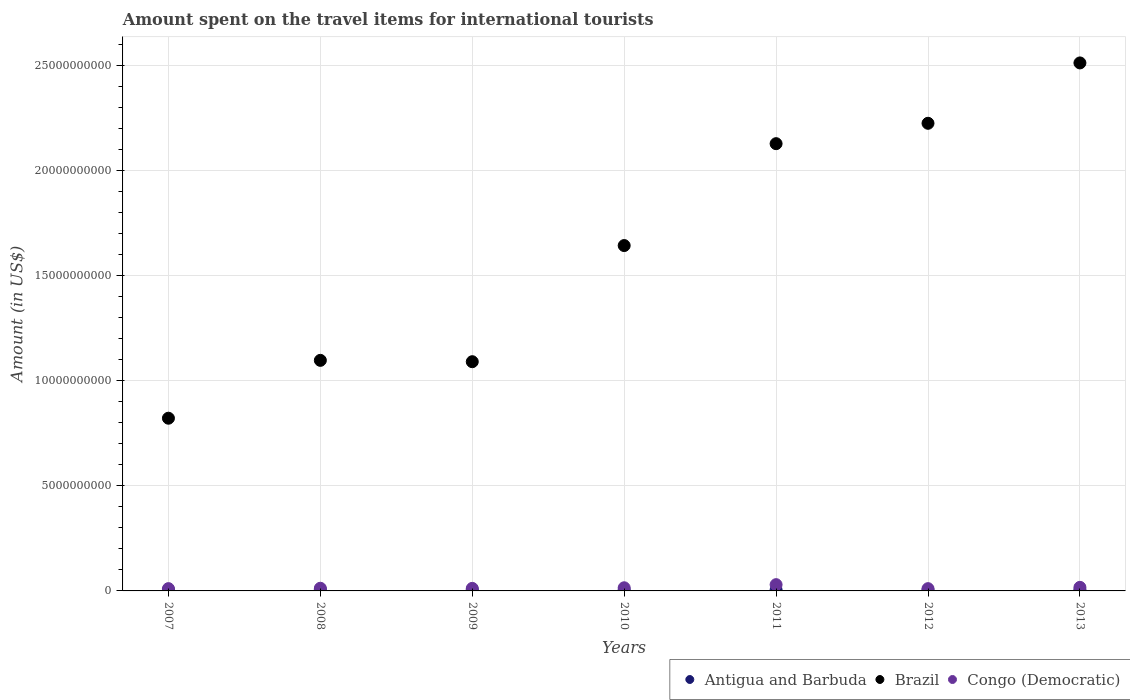How many different coloured dotlines are there?
Ensure brevity in your answer.  3. Is the number of dotlines equal to the number of legend labels?
Ensure brevity in your answer.  Yes. What is the amount spent on the travel items for international tourists in Antigua and Barbuda in 2012?
Offer a very short reply. 4.90e+07. Across all years, what is the maximum amount spent on the travel items for international tourists in Antigua and Barbuda?
Ensure brevity in your answer.  5.80e+07. Across all years, what is the minimum amount spent on the travel items for international tourists in Congo (Democratic)?
Give a very brief answer. 1.08e+08. In which year was the amount spent on the travel items for international tourists in Brazil minimum?
Make the answer very short. 2007. What is the total amount spent on the travel items for international tourists in Antigua and Barbuda in the graph?
Your answer should be compact. 3.63e+08. What is the difference between the amount spent on the travel items for international tourists in Congo (Democratic) in 2011 and that in 2013?
Your response must be concise. 1.28e+08. What is the difference between the amount spent on the travel items for international tourists in Antigua and Barbuda in 2011 and the amount spent on the travel items for international tourists in Congo (Democratic) in 2009?
Offer a terse response. -7.20e+07. What is the average amount spent on the travel items for international tourists in Antigua and Barbuda per year?
Your answer should be very brief. 5.19e+07. In the year 2011, what is the difference between the amount spent on the travel items for international tourists in Antigua and Barbuda and amount spent on the travel items for international tourists in Brazil?
Ensure brevity in your answer.  -2.12e+1. In how many years, is the amount spent on the travel items for international tourists in Antigua and Barbuda greater than 3000000000 US$?
Your response must be concise. 0. What is the ratio of the amount spent on the travel items for international tourists in Congo (Democratic) in 2008 to that in 2012?
Your answer should be compact. 1.18. Is the difference between the amount spent on the travel items for international tourists in Antigua and Barbuda in 2007 and 2012 greater than the difference between the amount spent on the travel items for international tourists in Brazil in 2007 and 2012?
Provide a short and direct response. Yes. What is the difference between the highest and the second highest amount spent on the travel items for international tourists in Brazil?
Your answer should be very brief. 2.87e+09. What is the difference between the highest and the lowest amount spent on the travel items for international tourists in Brazil?
Offer a terse response. 1.69e+1. In how many years, is the amount spent on the travel items for international tourists in Congo (Democratic) greater than the average amount spent on the travel items for international tourists in Congo (Democratic) taken over all years?
Provide a short and direct response. 2. Is the sum of the amount spent on the travel items for international tourists in Congo (Democratic) in 2007 and 2010 greater than the maximum amount spent on the travel items for international tourists in Antigua and Barbuda across all years?
Your response must be concise. Yes. Is it the case that in every year, the sum of the amount spent on the travel items for international tourists in Brazil and amount spent on the travel items for international tourists in Antigua and Barbuda  is greater than the amount spent on the travel items for international tourists in Congo (Democratic)?
Ensure brevity in your answer.  Yes. Is the amount spent on the travel items for international tourists in Antigua and Barbuda strictly less than the amount spent on the travel items for international tourists in Congo (Democratic) over the years?
Provide a succinct answer. Yes. How many dotlines are there?
Offer a terse response. 3. Does the graph contain grids?
Your answer should be very brief. Yes. Where does the legend appear in the graph?
Your response must be concise. Bottom right. What is the title of the graph?
Keep it short and to the point. Amount spent on the travel items for international tourists. What is the label or title of the X-axis?
Offer a terse response. Years. What is the Amount (in US$) of Antigua and Barbuda in 2007?
Keep it short and to the point. 5.20e+07. What is the Amount (in US$) in Brazil in 2007?
Make the answer very short. 8.21e+09. What is the Amount (in US$) of Congo (Democratic) in 2007?
Give a very brief answer. 1.09e+08. What is the Amount (in US$) in Antigua and Barbuda in 2008?
Your answer should be very brief. 5.80e+07. What is the Amount (in US$) in Brazil in 2008?
Keep it short and to the point. 1.10e+1. What is the Amount (in US$) of Congo (Democratic) in 2008?
Keep it short and to the point. 1.27e+08. What is the Amount (in US$) of Antigua and Barbuda in 2009?
Keep it short and to the point. 5.40e+07. What is the Amount (in US$) of Brazil in 2009?
Provide a succinct answer. 1.09e+1. What is the Amount (in US$) of Congo (Democratic) in 2009?
Provide a short and direct response. 1.21e+08. What is the Amount (in US$) of Antigua and Barbuda in 2010?
Your answer should be compact. 5.10e+07. What is the Amount (in US$) in Brazil in 2010?
Keep it short and to the point. 1.64e+1. What is the Amount (in US$) of Congo (Democratic) in 2010?
Offer a terse response. 1.50e+08. What is the Amount (in US$) of Antigua and Barbuda in 2011?
Make the answer very short. 4.90e+07. What is the Amount (in US$) of Brazil in 2011?
Offer a very short reply. 2.13e+1. What is the Amount (in US$) of Congo (Democratic) in 2011?
Provide a succinct answer. 2.98e+08. What is the Amount (in US$) in Antigua and Barbuda in 2012?
Ensure brevity in your answer.  4.90e+07. What is the Amount (in US$) of Brazil in 2012?
Ensure brevity in your answer.  2.22e+1. What is the Amount (in US$) in Congo (Democratic) in 2012?
Offer a terse response. 1.08e+08. What is the Amount (in US$) of Antigua and Barbuda in 2013?
Your answer should be compact. 5.00e+07. What is the Amount (in US$) in Brazil in 2013?
Provide a succinct answer. 2.51e+1. What is the Amount (in US$) of Congo (Democratic) in 2013?
Your response must be concise. 1.70e+08. Across all years, what is the maximum Amount (in US$) in Antigua and Barbuda?
Give a very brief answer. 5.80e+07. Across all years, what is the maximum Amount (in US$) of Brazil?
Your answer should be compact. 2.51e+1. Across all years, what is the maximum Amount (in US$) of Congo (Democratic)?
Make the answer very short. 2.98e+08. Across all years, what is the minimum Amount (in US$) of Antigua and Barbuda?
Your answer should be compact. 4.90e+07. Across all years, what is the minimum Amount (in US$) in Brazil?
Your answer should be compact. 8.21e+09. Across all years, what is the minimum Amount (in US$) of Congo (Democratic)?
Your answer should be compact. 1.08e+08. What is the total Amount (in US$) of Antigua and Barbuda in the graph?
Provide a short and direct response. 3.63e+08. What is the total Amount (in US$) of Brazil in the graph?
Ensure brevity in your answer.  1.15e+11. What is the total Amount (in US$) in Congo (Democratic) in the graph?
Your answer should be compact. 1.08e+09. What is the difference between the Amount (in US$) in Antigua and Barbuda in 2007 and that in 2008?
Make the answer very short. -6.00e+06. What is the difference between the Amount (in US$) in Brazil in 2007 and that in 2008?
Keep it short and to the point. -2.75e+09. What is the difference between the Amount (in US$) of Congo (Democratic) in 2007 and that in 2008?
Provide a succinct answer. -1.80e+07. What is the difference between the Amount (in US$) of Antigua and Barbuda in 2007 and that in 2009?
Provide a short and direct response. -2.00e+06. What is the difference between the Amount (in US$) of Brazil in 2007 and that in 2009?
Provide a succinct answer. -2.69e+09. What is the difference between the Amount (in US$) in Congo (Democratic) in 2007 and that in 2009?
Your answer should be compact. -1.20e+07. What is the difference between the Amount (in US$) of Antigua and Barbuda in 2007 and that in 2010?
Your answer should be compact. 1.00e+06. What is the difference between the Amount (in US$) in Brazil in 2007 and that in 2010?
Provide a short and direct response. -8.21e+09. What is the difference between the Amount (in US$) of Congo (Democratic) in 2007 and that in 2010?
Your response must be concise. -4.10e+07. What is the difference between the Amount (in US$) in Brazil in 2007 and that in 2011?
Ensure brevity in your answer.  -1.31e+1. What is the difference between the Amount (in US$) in Congo (Democratic) in 2007 and that in 2011?
Offer a very short reply. -1.89e+08. What is the difference between the Amount (in US$) of Antigua and Barbuda in 2007 and that in 2012?
Offer a very short reply. 3.00e+06. What is the difference between the Amount (in US$) of Brazil in 2007 and that in 2012?
Your answer should be very brief. -1.40e+1. What is the difference between the Amount (in US$) in Brazil in 2007 and that in 2013?
Your response must be concise. -1.69e+1. What is the difference between the Amount (in US$) of Congo (Democratic) in 2007 and that in 2013?
Give a very brief answer. -6.10e+07. What is the difference between the Amount (in US$) in Brazil in 2008 and that in 2009?
Your answer should be very brief. 6.40e+07. What is the difference between the Amount (in US$) in Congo (Democratic) in 2008 and that in 2009?
Keep it short and to the point. 6.00e+06. What is the difference between the Amount (in US$) of Antigua and Barbuda in 2008 and that in 2010?
Provide a short and direct response. 7.00e+06. What is the difference between the Amount (in US$) in Brazil in 2008 and that in 2010?
Your response must be concise. -5.46e+09. What is the difference between the Amount (in US$) of Congo (Democratic) in 2008 and that in 2010?
Give a very brief answer. -2.30e+07. What is the difference between the Amount (in US$) of Antigua and Barbuda in 2008 and that in 2011?
Give a very brief answer. 9.00e+06. What is the difference between the Amount (in US$) of Brazil in 2008 and that in 2011?
Give a very brief answer. -1.03e+1. What is the difference between the Amount (in US$) in Congo (Democratic) in 2008 and that in 2011?
Your answer should be very brief. -1.71e+08. What is the difference between the Amount (in US$) in Antigua and Barbuda in 2008 and that in 2012?
Your answer should be very brief. 9.00e+06. What is the difference between the Amount (in US$) in Brazil in 2008 and that in 2012?
Provide a short and direct response. -1.13e+1. What is the difference between the Amount (in US$) in Congo (Democratic) in 2008 and that in 2012?
Provide a short and direct response. 1.90e+07. What is the difference between the Amount (in US$) of Antigua and Barbuda in 2008 and that in 2013?
Offer a terse response. 8.00e+06. What is the difference between the Amount (in US$) in Brazil in 2008 and that in 2013?
Provide a succinct answer. -1.41e+1. What is the difference between the Amount (in US$) of Congo (Democratic) in 2008 and that in 2013?
Ensure brevity in your answer.  -4.30e+07. What is the difference between the Amount (in US$) in Brazil in 2009 and that in 2010?
Make the answer very short. -5.52e+09. What is the difference between the Amount (in US$) of Congo (Democratic) in 2009 and that in 2010?
Offer a very short reply. -2.90e+07. What is the difference between the Amount (in US$) of Brazil in 2009 and that in 2011?
Your answer should be very brief. -1.04e+1. What is the difference between the Amount (in US$) of Congo (Democratic) in 2009 and that in 2011?
Offer a terse response. -1.77e+08. What is the difference between the Amount (in US$) in Antigua and Barbuda in 2009 and that in 2012?
Make the answer very short. 5.00e+06. What is the difference between the Amount (in US$) of Brazil in 2009 and that in 2012?
Offer a terse response. -1.13e+1. What is the difference between the Amount (in US$) of Congo (Democratic) in 2009 and that in 2012?
Offer a very short reply. 1.30e+07. What is the difference between the Amount (in US$) in Antigua and Barbuda in 2009 and that in 2013?
Keep it short and to the point. 4.00e+06. What is the difference between the Amount (in US$) in Brazil in 2009 and that in 2013?
Your response must be concise. -1.42e+1. What is the difference between the Amount (in US$) in Congo (Democratic) in 2009 and that in 2013?
Your answer should be very brief. -4.90e+07. What is the difference between the Amount (in US$) of Antigua and Barbuda in 2010 and that in 2011?
Your answer should be compact. 2.00e+06. What is the difference between the Amount (in US$) of Brazil in 2010 and that in 2011?
Offer a terse response. -4.84e+09. What is the difference between the Amount (in US$) of Congo (Democratic) in 2010 and that in 2011?
Give a very brief answer. -1.48e+08. What is the difference between the Amount (in US$) in Brazil in 2010 and that in 2012?
Provide a succinct answer. -5.81e+09. What is the difference between the Amount (in US$) in Congo (Democratic) in 2010 and that in 2012?
Your answer should be compact. 4.20e+07. What is the difference between the Amount (in US$) in Brazil in 2010 and that in 2013?
Your answer should be compact. -8.68e+09. What is the difference between the Amount (in US$) in Congo (Democratic) in 2010 and that in 2013?
Offer a very short reply. -2.00e+07. What is the difference between the Amount (in US$) of Antigua and Barbuda in 2011 and that in 2012?
Your answer should be compact. 0. What is the difference between the Amount (in US$) of Brazil in 2011 and that in 2012?
Offer a very short reply. -9.69e+08. What is the difference between the Amount (in US$) of Congo (Democratic) in 2011 and that in 2012?
Offer a terse response. 1.90e+08. What is the difference between the Amount (in US$) of Brazil in 2011 and that in 2013?
Ensure brevity in your answer.  -3.84e+09. What is the difference between the Amount (in US$) of Congo (Democratic) in 2011 and that in 2013?
Your answer should be compact. 1.28e+08. What is the difference between the Amount (in US$) of Antigua and Barbuda in 2012 and that in 2013?
Your answer should be compact. -1.00e+06. What is the difference between the Amount (in US$) in Brazil in 2012 and that in 2013?
Make the answer very short. -2.87e+09. What is the difference between the Amount (in US$) in Congo (Democratic) in 2012 and that in 2013?
Your answer should be very brief. -6.20e+07. What is the difference between the Amount (in US$) of Antigua and Barbuda in 2007 and the Amount (in US$) of Brazil in 2008?
Provide a short and direct response. -1.09e+1. What is the difference between the Amount (in US$) in Antigua and Barbuda in 2007 and the Amount (in US$) in Congo (Democratic) in 2008?
Keep it short and to the point. -7.50e+07. What is the difference between the Amount (in US$) of Brazil in 2007 and the Amount (in US$) of Congo (Democratic) in 2008?
Your answer should be compact. 8.08e+09. What is the difference between the Amount (in US$) of Antigua and Barbuda in 2007 and the Amount (in US$) of Brazil in 2009?
Ensure brevity in your answer.  -1.08e+1. What is the difference between the Amount (in US$) of Antigua and Barbuda in 2007 and the Amount (in US$) of Congo (Democratic) in 2009?
Provide a short and direct response. -6.90e+07. What is the difference between the Amount (in US$) of Brazil in 2007 and the Amount (in US$) of Congo (Democratic) in 2009?
Offer a terse response. 8.09e+09. What is the difference between the Amount (in US$) in Antigua and Barbuda in 2007 and the Amount (in US$) in Brazil in 2010?
Your response must be concise. -1.64e+1. What is the difference between the Amount (in US$) of Antigua and Barbuda in 2007 and the Amount (in US$) of Congo (Democratic) in 2010?
Your answer should be compact. -9.80e+07. What is the difference between the Amount (in US$) in Brazil in 2007 and the Amount (in US$) in Congo (Democratic) in 2010?
Provide a short and direct response. 8.06e+09. What is the difference between the Amount (in US$) of Antigua and Barbuda in 2007 and the Amount (in US$) of Brazil in 2011?
Provide a short and direct response. -2.12e+1. What is the difference between the Amount (in US$) of Antigua and Barbuda in 2007 and the Amount (in US$) of Congo (Democratic) in 2011?
Your response must be concise. -2.46e+08. What is the difference between the Amount (in US$) of Brazil in 2007 and the Amount (in US$) of Congo (Democratic) in 2011?
Ensure brevity in your answer.  7.91e+09. What is the difference between the Amount (in US$) of Antigua and Barbuda in 2007 and the Amount (in US$) of Brazil in 2012?
Ensure brevity in your answer.  -2.22e+1. What is the difference between the Amount (in US$) of Antigua and Barbuda in 2007 and the Amount (in US$) of Congo (Democratic) in 2012?
Provide a succinct answer. -5.60e+07. What is the difference between the Amount (in US$) in Brazil in 2007 and the Amount (in US$) in Congo (Democratic) in 2012?
Your answer should be very brief. 8.10e+09. What is the difference between the Amount (in US$) in Antigua and Barbuda in 2007 and the Amount (in US$) in Brazil in 2013?
Your response must be concise. -2.51e+1. What is the difference between the Amount (in US$) in Antigua and Barbuda in 2007 and the Amount (in US$) in Congo (Democratic) in 2013?
Give a very brief answer. -1.18e+08. What is the difference between the Amount (in US$) of Brazil in 2007 and the Amount (in US$) of Congo (Democratic) in 2013?
Keep it short and to the point. 8.04e+09. What is the difference between the Amount (in US$) in Antigua and Barbuda in 2008 and the Amount (in US$) in Brazil in 2009?
Offer a very short reply. -1.08e+1. What is the difference between the Amount (in US$) of Antigua and Barbuda in 2008 and the Amount (in US$) of Congo (Democratic) in 2009?
Your answer should be very brief. -6.30e+07. What is the difference between the Amount (in US$) of Brazil in 2008 and the Amount (in US$) of Congo (Democratic) in 2009?
Make the answer very short. 1.08e+1. What is the difference between the Amount (in US$) in Antigua and Barbuda in 2008 and the Amount (in US$) in Brazil in 2010?
Provide a succinct answer. -1.64e+1. What is the difference between the Amount (in US$) of Antigua and Barbuda in 2008 and the Amount (in US$) of Congo (Democratic) in 2010?
Give a very brief answer. -9.20e+07. What is the difference between the Amount (in US$) in Brazil in 2008 and the Amount (in US$) in Congo (Democratic) in 2010?
Your answer should be very brief. 1.08e+1. What is the difference between the Amount (in US$) of Antigua and Barbuda in 2008 and the Amount (in US$) of Brazil in 2011?
Your answer should be compact. -2.12e+1. What is the difference between the Amount (in US$) of Antigua and Barbuda in 2008 and the Amount (in US$) of Congo (Democratic) in 2011?
Offer a very short reply. -2.40e+08. What is the difference between the Amount (in US$) of Brazil in 2008 and the Amount (in US$) of Congo (Democratic) in 2011?
Ensure brevity in your answer.  1.07e+1. What is the difference between the Amount (in US$) of Antigua and Barbuda in 2008 and the Amount (in US$) of Brazil in 2012?
Offer a very short reply. -2.22e+1. What is the difference between the Amount (in US$) in Antigua and Barbuda in 2008 and the Amount (in US$) in Congo (Democratic) in 2012?
Your response must be concise. -5.00e+07. What is the difference between the Amount (in US$) of Brazil in 2008 and the Amount (in US$) of Congo (Democratic) in 2012?
Provide a succinct answer. 1.09e+1. What is the difference between the Amount (in US$) in Antigua and Barbuda in 2008 and the Amount (in US$) in Brazil in 2013?
Provide a short and direct response. -2.50e+1. What is the difference between the Amount (in US$) of Antigua and Barbuda in 2008 and the Amount (in US$) of Congo (Democratic) in 2013?
Your answer should be compact. -1.12e+08. What is the difference between the Amount (in US$) in Brazil in 2008 and the Amount (in US$) in Congo (Democratic) in 2013?
Offer a terse response. 1.08e+1. What is the difference between the Amount (in US$) in Antigua and Barbuda in 2009 and the Amount (in US$) in Brazil in 2010?
Provide a short and direct response. -1.64e+1. What is the difference between the Amount (in US$) of Antigua and Barbuda in 2009 and the Amount (in US$) of Congo (Democratic) in 2010?
Give a very brief answer. -9.60e+07. What is the difference between the Amount (in US$) of Brazil in 2009 and the Amount (in US$) of Congo (Democratic) in 2010?
Your response must be concise. 1.07e+1. What is the difference between the Amount (in US$) in Antigua and Barbuda in 2009 and the Amount (in US$) in Brazil in 2011?
Provide a short and direct response. -2.12e+1. What is the difference between the Amount (in US$) in Antigua and Barbuda in 2009 and the Amount (in US$) in Congo (Democratic) in 2011?
Ensure brevity in your answer.  -2.44e+08. What is the difference between the Amount (in US$) of Brazil in 2009 and the Amount (in US$) of Congo (Democratic) in 2011?
Your response must be concise. 1.06e+1. What is the difference between the Amount (in US$) in Antigua and Barbuda in 2009 and the Amount (in US$) in Brazil in 2012?
Ensure brevity in your answer.  -2.22e+1. What is the difference between the Amount (in US$) of Antigua and Barbuda in 2009 and the Amount (in US$) of Congo (Democratic) in 2012?
Provide a succinct answer. -5.40e+07. What is the difference between the Amount (in US$) of Brazil in 2009 and the Amount (in US$) of Congo (Democratic) in 2012?
Ensure brevity in your answer.  1.08e+1. What is the difference between the Amount (in US$) in Antigua and Barbuda in 2009 and the Amount (in US$) in Brazil in 2013?
Ensure brevity in your answer.  -2.50e+1. What is the difference between the Amount (in US$) of Antigua and Barbuda in 2009 and the Amount (in US$) of Congo (Democratic) in 2013?
Your answer should be compact. -1.16e+08. What is the difference between the Amount (in US$) of Brazil in 2009 and the Amount (in US$) of Congo (Democratic) in 2013?
Provide a succinct answer. 1.07e+1. What is the difference between the Amount (in US$) in Antigua and Barbuda in 2010 and the Amount (in US$) in Brazil in 2011?
Ensure brevity in your answer.  -2.12e+1. What is the difference between the Amount (in US$) of Antigua and Barbuda in 2010 and the Amount (in US$) of Congo (Democratic) in 2011?
Offer a terse response. -2.47e+08. What is the difference between the Amount (in US$) of Brazil in 2010 and the Amount (in US$) of Congo (Democratic) in 2011?
Keep it short and to the point. 1.61e+1. What is the difference between the Amount (in US$) of Antigua and Barbuda in 2010 and the Amount (in US$) of Brazil in 2012?
Your answer should be compact. -2.22e+1. What is the difference between the Amount (in US$) in Antigua and Barbuda in 2010 and the Amount (in US$) in Congo (Democratic) in 2012?
Make the answer very short. -5.70e+07. What is the difference between the Amount (in US$) in Brazil in 2010 and the Amount (in US$) in Congo (Democratic) in 2012?
Ensure brevity in your answer.  1.63e+1. What is the difference between the Amount (in US$) in Antigua and Barbuda in 2010 and the Amount (in US$) in Brazil in 2013?
Keep it short and to the point. -2.51e+1. What is the difference between the Amount (in US$) in Antigua and Barbuda in 2010 and the Amount (in US$) in Congo (Democratic) in 2013?
Provide a short and direct response. -1.19e+08. What is the difference between the Amount (in US$) in Brazil in 2010 and the Amount (in US$) in Congo (Democratic) in 2013?
Give a very brief answer. 1.62e+1. What is the difference between the Amount (in US$) in Antigua and Barbuda in 2011 and the Amount (in US$) in Brazil in 2012?
Offer a very short reply. -2.22e+1. What is the difference between the Amount (in US$) in Antigua and Barbuda in 2011 and the Amount (in US$) in Congo (Democratic) in 2012?
Your answer should be very brief. -5.90e+07. What is the difference between the Amount (in US$) in Brazil in 2011 and the Amount (in US$) in Congo (Democratic) in 2012?
Provide a short and direct response. 2.12e+1. What is the difference between the Amount (in US$) in Antigua and Barbuda in 2011 and the Amount (in US$) in Brazil in 2013?
Make the answer very short. -2.51e+1. What is the difference between the Amount (in US$) in Antigua and Barbuda in 2011 and the Amount (in US$) in Congo (Democratic) in 2013?
Provide a short and direct response. -1.21e+08. What is the difference between the Amount (in US$) of Brazil in 2011 and the Amount (in US$) of Congo (Democratic) in 2013?
Your answer should be very brief. 2.11e+1. What is the difference between the Amount (in US$) in Antigua and Barbuda in 2012 and the Amount (in US$) in Brazil in 2013?
Your answer should be very brief. -2.51e+1. What is the difference between the Amount (in US$) of Antigua and Barbuda in 2012 and the Amount (in US$) of Congo (Democratic) in 2013?
Your response must be concise. -1.21e+08. What is the difference between the Amount (in US$) of Brazil in 2012 and the Amount (in US$) of Congo (Democratic) in 2013?
Give a very brief answer. 2.21e+1. What is the average Amount (in US$) of Antigua and Barbuda per year?
Ensure brevity in your answer.  5.19e+07. What is the average Amount (in US$) of Brazil per year?
Provide a succinct answer. 1.64e+1. What is the average Amount (in US$) of Congo (Democratic) per year?
Your response must be concise. 1.55e+08. In the year 2007, what is the difference between the Amount (in US$) in Antigua and Barbuda and Amount (in US$) in Brazil?
Provide a succinct answer. -8.16e+09. In the year 2007, what is the difference between the Amount (in US$) in Antigua and Barbuda and Amount (in US$) in Congo (Democratic)?
Ensure brevity in your answer.  -5.70e+07. In the year 2007, what is the difference between the Amount (in US$) in Brazil and Amount (in US$) in Congo (Democratic)?
Your answer should be very brief. 8.10e+09. In the year 2008, what is the difference between the Amount (in US$) of Antigua and Barbuda and Amount (in US$) of Brazil?
Give a very brief answer. -1.09e+1. In the year 2008, what is the difference between the Amount (in US$) in Antigua and Barbuda and Amount (in US$) in Congo (Democratic)?
Offer a terse response. -6.90e+07. In the year 2008, what is the difference between the Amount (in US$) in Brazil and Amount (in US$) in Congo (Democratic)?
Make the answer very short. 1.08e+1. In the year 2009, what is the difference between the Amount (in US$) in Antigua and Barbuda and Amount (in US$) in Brazil?
Offer a terse response. -1.08e+1. In the year 2009, what is the difference between the Amount (in US$) of Antigua and Barbuda and Amount (in US$) of Congo (Democratic)?
Offer a very short reply. -6.70e+07. In the year 2009, what is the difference between the Amount (in US$) of Brazil and Amount (in US$) of Congo (Democratic)?
Provide a succinct answer. 1.08e+1. In the year 2010, what is the difference between the Amount (in US$) in Antigua and Barbuda and Amount (in US$) in Brazil?
Provide a short and direct response. -1.64e+1. In the year 2010, what is the difference between the Amount (in US$) in Antigua and Barbuda and Amount (in US$) in Congo (Democratic)?
Provide a short and direct response. -9.90e+07. In the year 2010, what is the difference between the Amount (in US$) of Brazil and Amount (in US$) of Congo (Democratic)?
Keep it short and to the point. 1.63e+1. In the year 2011, what is the difference between the Amount (in US$) of Antigua and Barbuda and Amount (in US$) of Brazil?
Ensure brevity in your answer.  -2.12e+1. In the year 2011, what is the difference between the Amount (in US$) of Antigua and Barbuda and Amount (in US$) of Congo (Democratic)?
Offer a very short reply. -2.49e+08. In the year 2011, what is the difference between the Amount (in US$) of Brazil and Amount (in US$) of Congo (Democratic)?
Your answer should be compact. 2.10e+1. In the year 2012, what is the difference between the Amount (in US$) in Antigua and Barbuda and Amount (in US$) in Brazil?
Give a very brief answer. -2.22e+1. In the year 2012, what is the difference between the Amount (in US$) in Antigua and Barbuda and Amount (in US$) in Congo (Democratic)?
Give a very brief answer. -5.90e+07. In the year 2012, what is the difference between the Amount (in US$) in Brazil and Amount (in US$) in Congo (Democratic)?
Your answer should be very brief. 2.21e+1. In the year 2013, what is the difference between the Amount (in US$) of Antigua and Barbuda and Amount (in US$) of Brazil?
Provide a short and direct response. -2.51e+1. In the year 2013, what is the difference between the Amount (in US$) in Antigua and Barbuda and Amount (in US$) in Congo (Democratic)?
Give a very brief answer. -1.20e+08. In the year 2013, what is the difference between the Amount (in US$) of Brazil and Amount (in US$) of Congo (Democratic)?
Keep it short and to the point. 2.49e+1. What is the ratio of the Amount (in US$) in Antigua and Barbuda in 2007 to that in 2008?
Provide a succinct answer. 0.9. What is the ratio of the Amount (in US$) in Brazil in 2007 to that in 2008?
Ensure brevity in your answer.  0.75. What is the ratio of the Amount (in US$) in Congo (Democratic) in 2007 to that in 2008?
Offer a terse response. 0.86. What is the ratio of the Amount (in US$) of Antigua and Barbuda in 2007 to that in 2009?
Your answer should be very brief. 0.96. What is the ratio of the Amount (in US$) in Brazil in 2007 to that in 2009?
Provide a succinct answer. 0.75. What is the ratio of the Amount (in US$) in Congo (Democratic) in 2007 to that in 2009?
Give a very brief answer. 0.9. What is the ratio of the Amount (in US$) in Antigua and Barbuda in 2007 to that in 2010?
Offer a terse response. 1.02. What is the ratio of the Amount (in US$) of Brazil in 2007 to that in 2010?
Ensure brevity in your answer.  0.5. What is the ratio of the Amount (in US$) of Congo (Democratic) in 2007 to that in 2010?
Give a very brief answer. 0.73. What is the ratio of the Amount (in US$) in Antigua and Barbuda in 2007 to that in 2011?
Keep it short and to the point. 1.06. What is the ratio of the Amount (in US$) in Brazil in 2007 to that in 2011?
Make the answer very short. 0.39. What is the ratio of the Amount (in US$) in Congo (Democratic) in 2007 to that in 2011?
Your answer should be compact. 0.37. What is the ratio of the Amount (in US$) of Antigua and Barbuda in 2007 to that in 2012?
Keep it short and to the point. 1.06. What is the ratio of the Amount (in US$) of Brazil in 2007 to that in 2012?
Your answer should be very brief. 0.37. What is the ratio of the Amount (in US$) in Congo (Democratic) in 2007 to that in 2012?
Give a very brief answer. 1.01. What is the ratio of the Amount (in US$) of Antigua and Barbuda in 2007 to that in 2013?
Ensure brevity in your answer.  1.04. What is the ratio of the Amount (in US$) in Brazil in 2007 to that in 2013?
Give a very brief answer. 0.33. What is the ratio of the Amount (in US$) in Congo (Democratic) in 2007 to that in 2013?
Your answer should be very brief. 0.64. What is the ratio of the Amount (in US$) in Antigua and Barbuda in 2008 to that in 2009?
Your response must be concise. 1.07. What is the ratio of the Amount (in US$) in Brazil in 2008 to that in 2009?
Provide a short and direct response. 1.01. What is the ratio of the Amount (in US$) of Congo (Democratic) in 2008 to that in 2009?
Your answer should be compact. 1.05. What is the ratio of the Amount (in US$) of Antigua and Barbuda in 2008 to that in 2010?
Provide a succinct answer. 1.14. What is the ratio of the Amount (in US$) of Brazil in 2008 to that in 2010?
Keep it short and to the point. 0.67. What is the ratio of the Amount (in US$) of Congo (Democratic) in 2008 to that in 2010?
Provide a short and direct response. 0.85. What is the ratio of the Amount (in US$) of Antigua and Barbuda in 2008 to that in 2011?
Ensure brevity in your answer.  1.18. What is the ratio of the Amount (in US$) of Brazil in 2008 to that in 2011?
Your answer should be compact. 0.52. What is the ratio of the Amount (in US$) in Congo (Democratic) in 2008 to that in 2011?
Keep it short and to the point. 0.43. What is the ratio of the Amount (in US$) in Antigua and Barbuda in 2008 to that in 2012?
Give a very brief answer. 1.18. What is the ratio of the Amount (in US$) in Brazil in 2008 to that in 2012?
Offer a very short reply. 0.49. What is the ratio of the Amount (in US$) of Congo (Democratic) in 2008 to that in 2012?
Ensure brevity in your answer.  1.18. What is the ratio of the Amount (in US$) in Antigua and Barbuda in 2008 to that in 2013?
Keep it short and to the point. 1.16. What is the ratio of the Amount (in US$) in Brazil in 2008 to that in 2013?
Provide a succinct answer. 0.44. What is the ratio of the Amount (in US$) of Congo (Democratic) in 2008 to that in 2013?
Keep it short and to the point. 0.75. What is the ratio of the Amount (in US$) in Antigua and Barbuda in 2009 to that in 2010?
Keep it short and to the point. 1.06. What is the ratio of the Amount (in US$) in Brazil in 2009 to that in 2010?
Offer a terse response. 0.66. What is the ratio of the Amount (in US$) in Congo (Democratic) in 2009 to that in 2010?
Keep it short and to the point. 0.81. What is the ratio of the Amount (in US$) in Antigua and Barbuda in 2009 to that in 2011?
Make the answer very short. 1.1. What is the ratio of the Amount (in US$) in Brazil in 2009 to that in 2011?
Provide a succinct answer. 0.51. What is the ratio of the Amount (in US$) in Congo (Democratic) in 2009 to that in 2011?
Provide a short and direct response. 0.41. What is the ratio of the Amount (in US$) in Antigua and Barbuda in 2009 to that in 2012?
Your answer should be compact. 1.1. What is the ratio of the Amount (in US$) of Brazil in 2009 to that in 2012?
Keep it short and to the point. 0.49. What is the ratio of the Amount (in US$) in Congo (Democratic) in 2009 to that in 2012?
Ensure brevity in your answer.  1.12. What is the ratio of the Amount (in US$) in Antigua and Barbuda in 2009 to that in 2013?
Give a very brief answer. 1.08. What is the ratio of the Amount (in US$) in Brazil in 2009 to that in 2013?
Your answer should be compact. 0.43. What is the ratio of the Amount (in US$) of Congo (Democratic) in 2009 to that in 2013?
Your response must be concise. 0.71. What is the ratio of the Amount (in US$) in Antigua and Barbuda in 2010 to that in 2011?
Provide a succinct answer. 1.04. What is the ratio of the Amount (in US$) of Brazil in 2010 to that in 2011?
Offer a terse response. 0.77. What is the ratio of the Amount (in US$) of Congo (Democratic) in 2010 to that in 2011?
Your answer should be compact. 0.5. What is the ratio of the Amount (in US$) of Antigua and Barbuda in 2010 to that in 2012?
Make the answer very short. 1.04. What is the ratio of the Amount (in US$) of Brazil in 2010 to that in 2012?
Give a very brief answer. 0.74. What is the ratio of the Amount (in US$) in Congo (Democratic) in 2010 to that in 2012?
Ensure brevity in your answer.  1.39. What is the ratio of the Amount (in US$) of Antigua and Barbuda in 2010 to that in 2013?
Provide a short and direct response. 1.02. What is the ratio of the Amount (in US$) of Brazil in 2010 to that in 2013?
Offer a very short reply. 0.65. What is the ratio of the Amount (in US$) in Congo (Democratic) in 2010 to that in 2013?
Provide a short and direct response. 0.88. What is the ratio of the Amount (in US$) in Brazil in 2011 to that in 2012?
Offer a terse response. 0.96. What is the ratio of the Amount (in US$) of Congo (Democratic) in 2011 to that in 2012?
Provide a succinct answer. 2.76. What is the ratio of the Amount (in US$) of Antigua and Barbuda in 2011 to that in 2013?
Your answer should be compact. 0.98. What is the ratio of the Amount (in US$) of Brazil in 2011 to that in 2013?
Offer a terse response. 0.85. What is the ratio of the Amount (in US$) in Congo (Democratic) in 2011 to that in 2013?
Your response must be concise. 1.75. What is the ratio of the Amount (in US$) of Brazil in 2012 to that in 2013?
Provide a short and direct response. 0.89. What is the ratio of the Amount (in US$) in Congo (Democratic) in 2012 to that in 2013?
Provide a short and direct response. 0.64. What is the difference between the highest and the second highest Amount (in US$) in Brazil?
Make the answer very short. 2.87e+09. What is the difference between the highest and the second highest Amount (in US$) of Congo (Democratic)?
Ensure brevity in your answer.  1.28e+08. What is the difference between the highest and the lowest Amount (in US$) in Antigua and Barbuda?
Your answer should be very brief. 9.00e+06. What is the difference between the highest and the lowest Amount (in US$) of Brazil?
Your response must be concise. 1.69e+1. What is the difference between the highest and the lowest Amount (in US$) in Congo (Democratic)?
Offer a very short reply. 1.90e+08. 